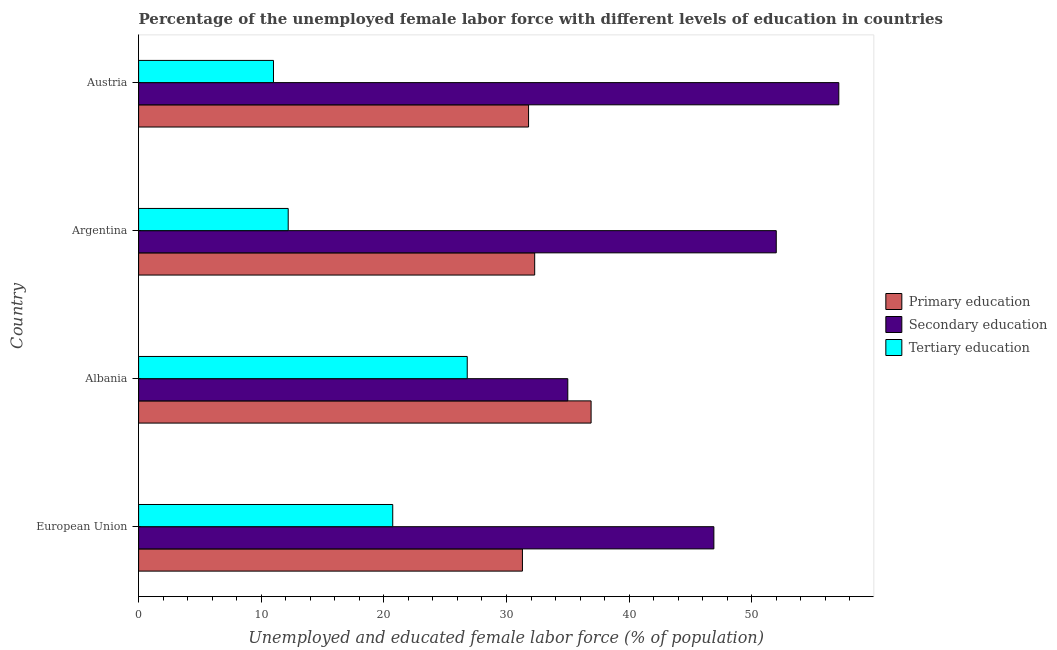How many different coloured bars are there?
Your answer should be very brief. 3. Are the number of bars on each tick of the Y-axis equal?
Give a very brief answer. Yes. How many bars are there on the 3rd tick from the bottom?
Keep it short and to the point. 3. What is the label of the 4th group of bars from the top?
Provide a succinct answer. European Union. In how many cases, is the number of bars for a given country not equal to the number of legend labels?
Offer a very short reply. 0. What is the percentage of female labor force who received tertiary education in Albania?
Ensure brevity in your answer.  26.8. Across all countries, what is the maximum percentage of female labor force who received primary education?
Your answer should be compact. 36.9. Across all countries, what is the minimum percentage of female labor force who received primary education?
Make the answer very short. 31.3. In which country was the percentage of female labor force who received primary education maximum?
Make the answer very short. Albania. In which country was the percentage of female labor force who received primary education minimum?
Keep it short and to the point. European Union. What is the total percentage of female labor force who received secondary education in the graph?
Keep it short and to the point. 191.01. What is the difference between the percentage of female labor force who received tertiary education in Austria and that in European Union?
Your response must be concise. -9.72. What is the difference between the percentage of female labor force who received primary education in Albania and the percentage of female labor force who received tertiary education in Austria?
Offer a terse response. 25.9. What is the average percentage of female labor force who received tertiary education per country?
Offer a very short reply. 17.68. What is the difference between the percentage of female labor force who received tertiary education and percentage of female labor force who received primary education in Argentina?
Keep it short and to the point. -20.1. What is the ratio of the percentage of female labor force who received tertiary education in Albania to that in Argentina?
Keep it short and to the point. 2.2. Is the percentage of female labor force who received secondary education in Albania less than that in European Union?
Offer a terse response. Yes. What is the difference between the highest and the lowest percentage of female labor force who received secondary education?
Provide a succinct answer. 22.1. What does the 1st bar from the top in Argentina represents?
Your response must be concise. Tertiary education. Is it the case that in every country, the sum of the percentage of female labor force who received primary education and percentage of female labor force who received secondary education is greater than the percentage of female labor force who received tertiary education?
Your answer should be compact. Yes. How many bars are there?
Keep it short and to the point. 12. How many countries are there in the graph?
Your response must be concise. 4. Does the graph contain grids?
Your response must be concise. No. How are the legend labels stacked?
Provide a short and direct response. Vertical. What is the title of the graph?
Your response must be concise. Percentage of the unemployed female labor force with different levels of education in countries. What is the label or title of the X-axis?
Offer a very short reply. Unemployed and educated female labor force (% of population). What is the label or title of the Y-axis?
Offer a terse response. Country. What is the Unemployed and educated female labor force (% of population) of Primary education in European Union?
Make the answer very short. 31.3. What is the Unemployed and educated female labor force (% of population) of Secondary education in European Union?
Make the answer very short. 46.91. What is the Unemployed and educated female labor force (% of population) in Tertiary education in European Union?
Your response must be concise. 20.72. What is the Unemployed and educated female labor force (% of population) of Primary education in Albania?
Give a very brief answer. 36.9. What is the Unemployed and educated female labor force (% of population) of Secondary education in Albania?
Give a very brief answer. 35. What is the Unemployed and educated female labor force (% of population) in Tertiary education in Albania?
Your answer should be very brief. 26.8. What is the Unemployed and educated female labor force (% of population) in Primary education in Argentina?
Make the answer very short. 32.3. What is the Unemployed and educated female labor force (% of population) in Secondary education in Argentina?
Make the answer very short. 52. What is the Unemployed and educated female labor force (% of population) of Tertiary education in Argentina?
Offer a terse response. 12.2. What is the Unemployed and educated female labor force (% of population) in Primary education in Austria?
Make the answer very short. 31.8. What is the Unemployed and educated female labor force (% of population) of Secondary education in Austria?
Keep it short and to the point. 57.1. Across all countries, what is the maximum Unemployed and educated female labor force (% of population) of Primary education?
Offer a terse response. 36.9. Across all countries, what is the maximum Unemployed and educated female labor force (% of population) in Secondary education?
Your response must be concise. 57.1. Across all countries, what is the maximum Unemployed and educated female labor force (% of population) of Tertiary education?
Ensure brevity in your answer.  26.8. Across all countries, what is the minimum Unemployed and educated female labor force (% of population) in Primary education?
Make the answer very short. 31.3. Across all countries, what is the minimum Unemployed and educated female labor force (% of population) of Tertiary education?
Ensure brevity in your answer.  11. What is the total Unemployed and educated female labor force (% of population) in Primary education in the graph?
Offer a terse response. 132.3. What is the total Unemployed and educated female labor force (% of population) in Secondary education in the graph?
Your answer should be very brief. 191.01. What is the total Unemployed and educated female labor force (% of population) of Tertiary education in the graph?
Your answer should be compact. 70.72. What is the difference between the Unemployed and educated female labor force (% of population) in Primary education in European Union and that in Albania?
Keep it short and to the point. -5.6. What is the difference between the Unemployed and educated female labor force (% of population) of Secondary education in European Union and that in Albania?
Ensure brevity in your answer.  11.91. What is the difference between the Unemployed and educated female labor force (% of population) in Tertiary education in European Union and that in Albania?
Give a very brief answer. -6.08. What is the difference between the Unemployed and educated female labor force (% of population) in Primary education in European Union and that in Argentina?
Your response must be concise. -1. What is the difference between the Unemployed and educated female labor force (% of population) of Secondary education in European Union and that in Argentina?
Give a very brief answer. -5.09. What is the difference between the Unemployed and educated female labor force (% of population) in Tertiary education in European Union and that in Argentina?
Provide a short and direct response. 8.52. What is the difference between the Unemployed and educated female labor force (% of population) in Primary education in European Union and that in Austria?
Provide a short and direct response. -0.5. What is the difference between the Unemployed and educated female labor force (% of population) in Secondary education in European Union and that in Austria?
Ensure brevity in your answer.  -10.19. What is the difference between the Unemployed and educated female labor force (% of population) in Tertiary education in European Union and that in Austria?
Make the answer very short. 9.72. What is the difference between the Unemployed and educated female labor force (% of population) of Primary education in Albania and that in Argentina?
Offer a very short reply. 4.6. What is the difference between the Unemployed and educated female labor force (% of population) of Tertiary education in Albania and that in Argentina?
Keep it short and to the point. 14.6. What is the difference between the Unemployed and educated female labor force (% of population) in Primary education in Albania and that in Austria?
Make the answer very short. 5.1. What is the difference between the Unemployed and educated female labor force (% of population) in Secondary education in Albania and that in Austria?
Keep it short and to the point. -22.1. What is the difference between the Unemployed and educated female labor force (% of population) in Primary education in Argentina and that in Austria?
Keep it short and to the point. 0.5. What is the difference between the Unemployed and educated female labor force (% of population) of Tertiary education in Argentina and that in Austria?
Offer a terse response. 1.2. What is the difference between the Unemployed and educated female labor force (% of population) of Primary education in European Union and the Unemployed and educated female labor force (% of population) of Secondary education in Albania?
Ensure brevity in your answer.  -3.7. What is the difference between the Unemployed and educated female labor force (% of population) in Primary education in European Union and the Unemployed and educated female labor force (% of population) in Tertiary education in Albania?
Provide a succinct answer. 4.5. What is the difference between the Unemployed and educated female labor force (% of population) in Secondary education in European Union and the Unemployed and educated female labor force (% of population) in Tertiary education in Albania?
Keep it short and to the point. 20.11. What is the difference between the Unemployed and educated female labor force (% of population) of Primary education in European Union and the Unemployed and educated female labor force (% of population) of Secondary education in Argentina?
Your answer should be very brief. -20.7. What is the difference between the Unemployed and educated female labor force (% of population) in Primary education in European Union and the Unemployed and educated female labor force (% of population) in Tertiary education in Argentina?
Ensure brevity in your answer.  19.1. What is the difference between the Unemployed and educated female labor force (% of population) in Secondary education in European Union and the Unemployed and educated female labor force (% of population) in Tertiary education in Argentina?
Provide a succinct answer. 34.71. What is the difference between the Unemployed and educated female labor force (% of population) in Primary education in European Union and the Unemployed and educated female labor force (% of population) in Secondary education in Austria?
Provide a short and direct response. -25.8. What is the difference between the Unemployed and educated female labor force (% of population) of Primary education in European Union and the Unemployed and educated female labor force (% of population) of Tertiary education in Austria?
Ensure brevity in your answer.  20.3. What is the difference between the Unemployed and educated female labor force (% of population) of Secondary education in European Union and the Unemployed and educated female labor force (% of population) of Tertiary education in Austria?
Your answer should be compact. 35.91. What is the difference between the Unemployed and educated female labor force (% of population) in Primary education in Albania and the Unemployed and educated female labor force (% of population) in Secondary education in Argentina?
Keep it short and to the point. -15.1. What is the difference between the Unemployed and educated female labor force (% of population) of Primary education in Albania and the Unemployed and educated female labor force (% of population) of Tertiary education in Argentina?
Offer a very short reply. 24.7. What is the difference between the Unemployed and educated female labor force (% of population) of Secondary education in Albania and the Unemployed and educated female labor force (% of population) of Tertiary education in Argentina?
Give a very brief answer. 22.8. What is the difference between the Unemployed and educated female labor force (% of population) in Primary education in Albania and the Unemployed and educated female labor force (% of population) in Secondary education in Austria?
Your answer should be very brief. -20.2. What is the difference between the Unemployed and educated female labor force (% of population) in Primary education in Albania and the Unemployed and educated female labor force (% of population) in Tertiary education in Austria?
Provide a succinct answer. 25.9. What is the difference between the Unemployed and educated female labor force (% of population) in Primary education in Argentina and the Unemployed and educated female labor force (% of population) in Secondary education in Austria?
Provide a short and direct response. -24.8. What is the difference between the Unemployed and educated female labor force (% of population) of Primary education in Argentina and the Unemployed and educated female labor force (% of population) of Tertiary education in Austria?
Offer a terse response. 21.3. What is the difference between the Unemployed and educated female labor force (% of population) of Secondary education in Argentina and the Unemployed and educated female labor force (% of population) of Tertiary education in Austria?
Keep it short and to the point. 41. What is the average Unemployed and educated female labor force (% of population) in Primary education per country?
Give a very brief answer. 33.08. What is the average Unemployed and educated female labor force (% of population) in Secondary education per country?
Offer a very short reply. 47.75. What is the average Unemployed and educated female labor force (% of population) in Tertiary education per country?
Offer a very short reply. 17.68. What is the difference between the Unemployed and educated female labor force (% of population) in Primary education and Unemployed and educated female labor force (% of population) in Secondary education in European Union?
Give a very brief answer. -15.61. What is the difference between the Unemployed and educated female labor force (% of population) in Primary education and Unemployed and educated female labor force (% of population) in Tertiary education in European Union?
Give a very brief answer. 10.58. What is the difference between the Unemployed and educated female labor force (% of population) in Secondary education and Unemployed and educated female labor force (% of population) in Tertiary education in European Union?
Make the answer very short. 26.19. What is the difference between the Unemployed and educated female labor force (% of population) in Primary education and Unemployed and educated female labor force (% of population) in Tertiary education in Albania?
Offer a very short reply. 10.1. What is the difference between the Unemployed and educated female labor force (% of population) in Primary education and Unemployed and educated female labor force (% of population) in Secondary education in Argentina?
Ensure brevity in your answer.  -19.7. What is the difference between the Unemployed and educated female labor force (% of population) of Primary education and Unemployed and educated female labor force (% of population) of Tertiary education in Argentina?
Your answer should be compact. 20.1. What is the difference between the Unemployed and educated female labor force (% of population) of Secondary education and Unemployed and educated female labor force (% of population) of Tertiary education in Argentina?
Give a very brief answer. 39.8. What is the difference between the Unemployed and educated female labor force (% of population) of Primary education and Unemployed and educated female labor force (% of population) of Secondary education in Austria?
Offer a terse response. -25.3. What is the difference between the Unemployed and educated female labor force (% of population) in Primary education and Unemployed and educated female labor force (% of population) in Tertiary education in Austria?
Offer a very short reply. 20.8. What is the difference between the Unemployed and educated female labor force (% of population) of Secondary education and Unemployed and educated female labor force (% of population) of Tertiary education in Austria?
Keep it short and to the point. 46.1. What is the ratio of the Unemployed and educated female labor force (% of population) in Primary education in European Union to that in Albania?
Provide a succinct answer. 0.85. What is the ratio of the Unemployed and educated female labor force (% of population) in Secondary education in European Union to that in Albania?
Give a very brief answer. 1.34. What is the ratio of the Unemployed and educated female labor force (% of population) in Tertiary education in European Union to that in Albania?
Ensure brevity in your answer.  0.77. What is the ratio of the Unemployed and educated female labor force (% of population) in Primary education in European Union to that in Argentina?
Give a very brief answer. 0.97. What is the ratio of the Unemployed and educated female labor force (% of population) of Secondary education in European Union to that in Argentina?
Offer a very short reply. 0.9. What is the ratio of the Unemployed and educated female labor force (% of population) in Tertiary education in European Union to that in Argentina?
Offer a very short reply. 1.7. What is the ratio of the Unemployed and educated female labor force (% of population) in Primary education in European Union to that in Austria?
Your response must be concise. 0.98. What is the ratio of the Unemployed and educated female labor force (% of population) in Secondary education in European Union to that in Austria?
Ensure brevity in your answer.  0.82. What is the ratio of the Unemployed and educated female labor force (% of population) of Tertiary education in European Union to that in Austria?
Your answer should be compact. 1.88. What is the ratio of the Unemployed and educated female labor force (% of population) of Primary education in Albania to that in Argentina?
Your response must be concise. 1.14. What is the ratio of the Unemployed and educated female labor force (% of population) of Secondary education in Albania to that in Argentina?
Ensure brevity in your answer.  0.67. What is the ratio of the Unemployed and educated female labor force (% of population) of Tertiary education in Albania to that in Argentina?
Give a very brief answer. 2.2. What is the ratio of the Unemployed and educated female labor force (% of population) of Primary education in Albania to that in Austria?
Keep it short and to the point. 1.16. What is the ratio of the Unemployed and educated female labor force (% of population) of Secondary education in Albania to that in Austria?
Your answer should be very brief. 0.61. What is the ratio of the Unemployed and educated female labor force (% of population) in Tertiary education in Albania to that in Austria?
Provide a succinct answer. 2.44. What is the ratio of the Unemployed and educated female labor force (% of population) of Primary education in Argentina to that in Austria?
Offer a terse response. 1.02. What is the ratio of the Unemployed and educated female labor force (% of population) in Secondary education in Argentina to that in Austria?
Offer a terse response. 0.91. What is the ratio of the Unemployed and educated female labor force (% of population) in Tertiary education in Argentina to that in Austria?
Make the answer very short. 1.11. What is the difference between the highest and the second highest Unemployed and educated female labor force (% of population) of Tertiary education?
Provide a succinct answer. 6.08. What is the difference between the highest and the lowest Unemployed and educated female labor force (% of population) of Primary education?
Your answer should be compact. 5.6. What is the difference between the highest and the lowest Unemployed and educated female labor force (% of population) in Secondary education?
Provide a succinct answer. 22.1. 